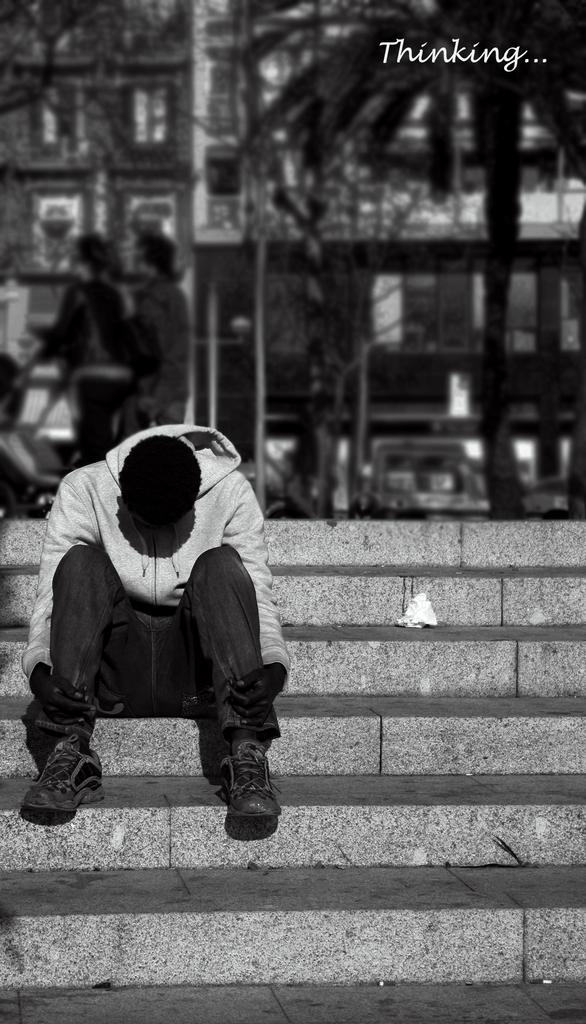How many people are in the image? There are three persons in the image. What are the people doing in the image? One person is sitting on the stairs. What type of vegetation can be seen in the image? There are trees in the image. What else can be seen in the image besides the people and trees? There are vehicles and buildings in the image. What type of jewel is the person wearing on their head in the image? There is no person wearing a jewel on their head in the image. What does the caption say about the image? There is no caption present in the image. 